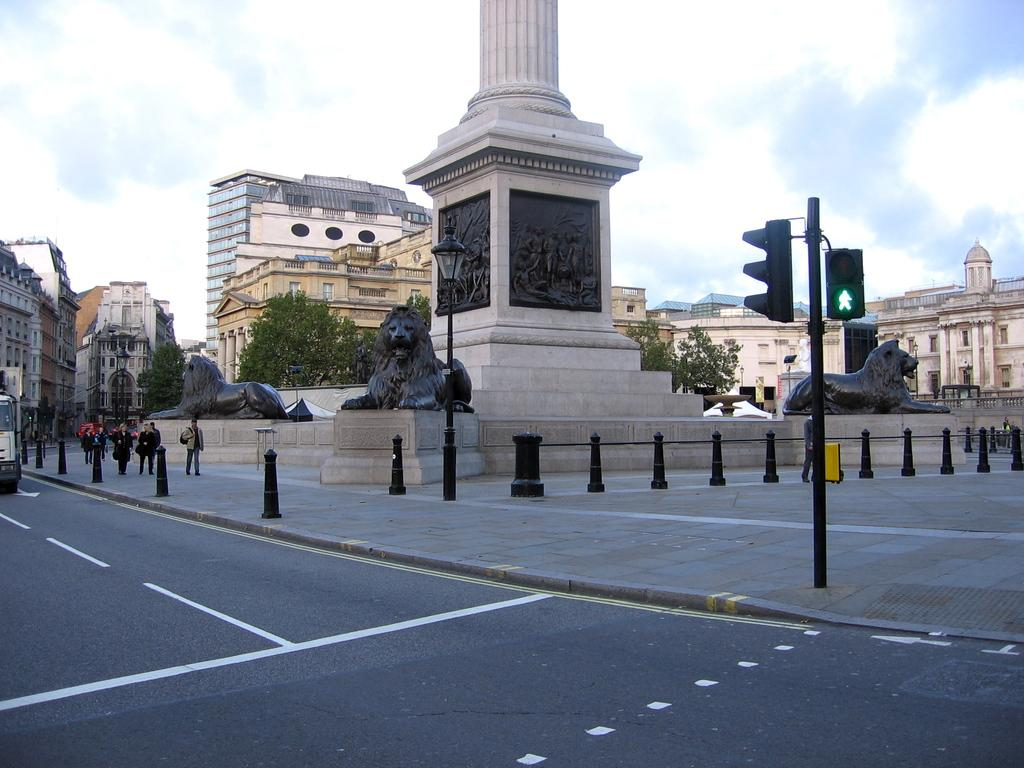What type of structures can be seen in the image? There are buildings in the image. What other natural elements are present in the image? There are trees in the image. Are there any artistic features in the image? Yes, there are statues in the image. What type of traffic control devices are visible in the image? There are traffic signals in the image. What is the general activity of the people in the image? There are people walking in the image. What type of lighting is present in the image? There is a street lamp in the image. What mode of transportation can be seen in the image? There is a vehicle in the image. What is visible in the sky in the image? The sky is visible in the image, and there are clouds present. What type of drug can be seen in the image? There is no drug present in the image. Can you compare the colors of the clouds in the image to the colors of the buildings? The question cannot be answered definitively as the colors of the clouds and buildings are not mentioned in the facts provided. 